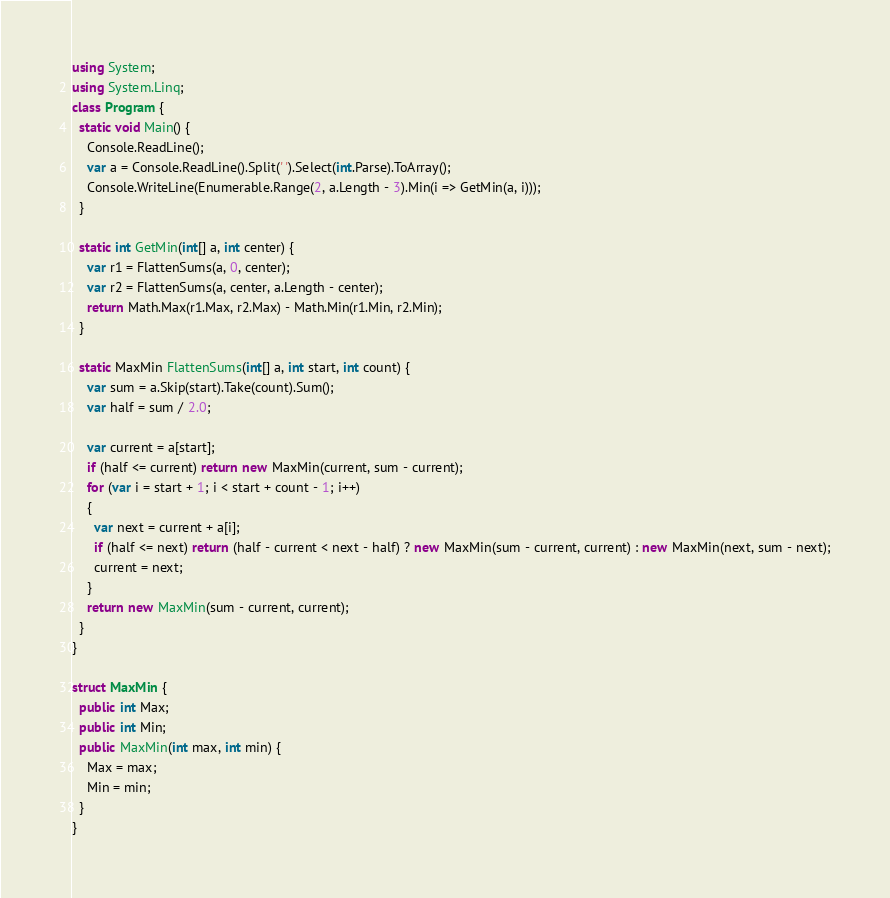<code> <loc_0><loc_0><loc_500><loc_500><_C#_>using System;
using System.Linq;
class Program {
  static void Main() {
    Console.ReadLine();
    var a = Console.ReadLine().Split(' ').Select(int.Parse).ToArray();
    Console.WriteLine(Enumerable.Range(2, a.Length - 3).Min(i => GetMin(a, i)));
  }

  static int GetMin(int[] a, int center) {
    var r1 = FlattenSums(a, 0, center);
    var r2 = FlattenSums(a, center, a.Length - center);
    return Math.Max(r1.Max, r2.Max) - Math.Min(r1.Min, r2.Min);
  }

  static MaxMin FlattenSums(int[] a, int start, int count) {
    var sum = a.Skip(start).Take(count).Sum();
    var half = sum / 2.0;

    var current = a[start];
    if (half <= current) return new MaxMin(current, sum - current);
    for (var i = start + 1; i < start + count - 1; i++)
    {
      var next = current + a[i];
      if (half <= next) return (half - current < next - half) ? new MaxMin(sum - current, current) : new MaxMin(next, sum - next);
      current = next;
    }
    return new MaxMin(sum - current, current);
  }
}

struct MaxMin {
  public int Max;
  public int Min;
  public MaxMin(int max, int min) {
    Max = max;
    Min = min;
  }
}
</code> 